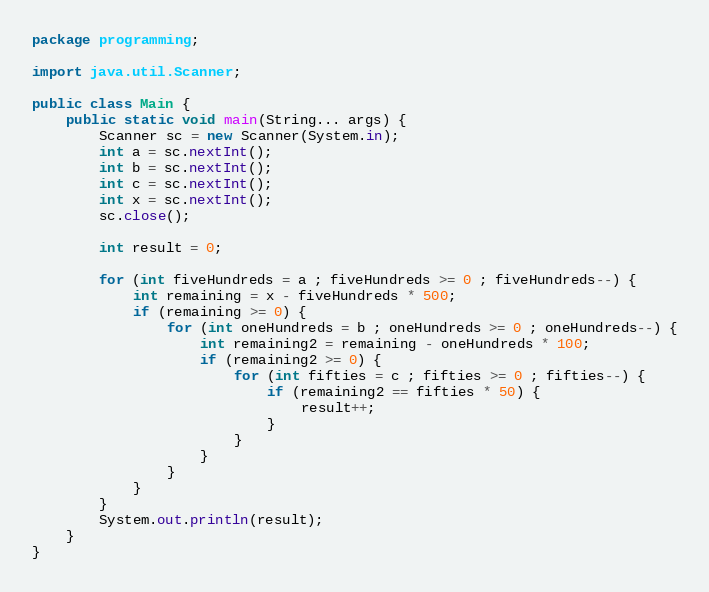<code> <loc_0><loc_0><loc_500><loc_500><_Java_>package programming;

import java.util.Scanner;

public class Main {
	public static void main(String... args) {
		Scanner sc = new Scanner(System.in);
		int a = sc.nextInt();
		int b = sc.nextInt();
		int c = sc.nextInt();
		int x = sc.nextInt();
		sc.close();

		int result = 0;

		for (int fiveHundreds = a ; fiveHundreds >= 0 ; fiveHundreds--) {
			int remaining = x - fiveHundreds * 500;
			if (remaining >= 0) {
				for (int oneHundreds = b ; oneHundreds >= 0 ; oneHundreds--) {
					int remaining2 = remaining - oneHundreds * 100;
					if (remaining2 >= 0) {
						for (int fifties = c ; fifties >= 0 ; fifties--) {
							if (remaining2 == fifties * 50) {
								result++;
							}
						}
					}
				}
			}
		}
		System.out.println(result);
	}
}
</code> 